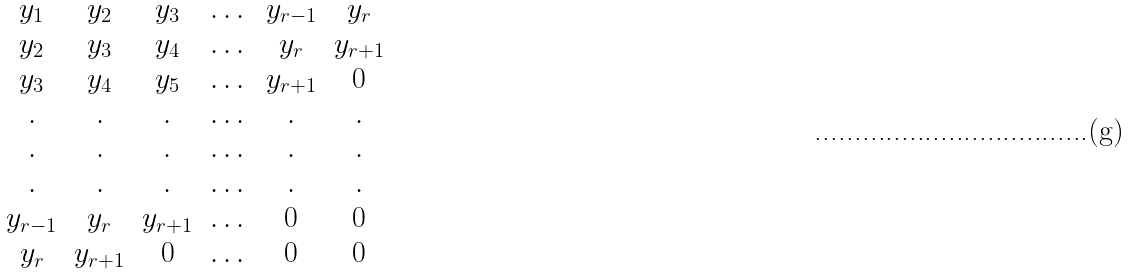<formula> <loc_0><loc_0><loc_500><loc_500>\begin{matrix} y _ { 1 } & y _ { 2 } & y _ { 3 } & \dots & y _ { r - 1 } & y _ { r } \\ y _ { 2 } & y _ { 3 } & y _ { 4 } & \dots & y _ { r } & y _ { r + 1 } \\ y _ { 3 } & y _ { 4 } & y _ { 5 } & \dots & y _ { r + 1 } & 0 \\ . & . & . & \dots & . & . \\ . & . & . & \dots & . & . \\ . & . & . & \dots & . & . \\ y _ { r - 1 } & y _ { r } & y _ { r + 1 } & \dots & 0 & 0 \\ y _ { r } & y _ { r + 1 } & 0 & \dots & 0 & 0 \\ \end{matrix}</formula> 